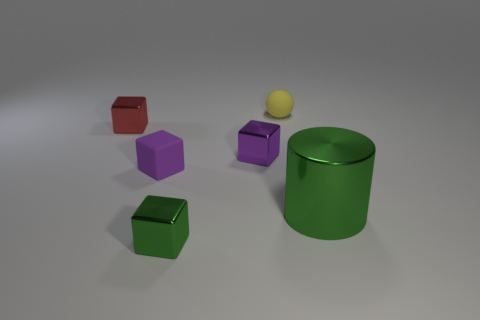Are there any other things that are the same material as the small red block?
Provide a succinct answer. Yes. Are there any other things that are the same color as the big cylinder?
Ensure brevity in your answer.  Yes. There is a metal block on the right side of the block in front of the big green thing; what is its color?
Ensure brevity in your answer.  Purple. There is a matte object that is the same shape as the purple metallic object; what is its size?
Your answer should be compact. Small. How many green things have the same material as the tiny red object?
Provide a short and direct response. 2. How many yellow things are to the left of the tiny thing behind the tiny red metal object?
Keep it short and to the point. 0. Are there any tiny purple blocks in front of the yellow rubber object?
Your response must be concise. Yes. There is a tiny matte object to the left of the small green cube; is its shape the same as the small red metal thing?
Your answer should be compact. Yes. How many objects are the same color as the metallic cylinder?
Ensure brevity in your answer.  1. The tiny matte thing behind the matte thing in front of the red block is what shape?
Your answer should be compact. Sphere. 